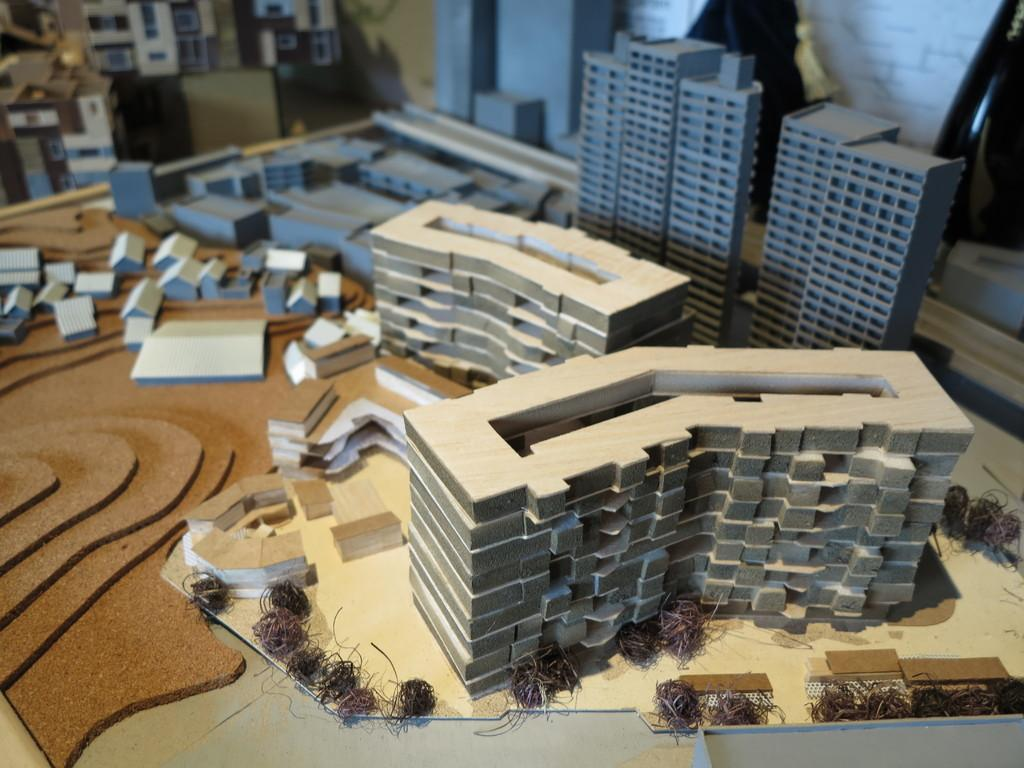What can be seen on the table in the foreground of the image? There is a model representation of a city on a table in the foreground. What is located on the left top of the image? There is another model on the left top of the image. What can be found on the right top of the image? There are objects on the right top of the image. How many apples are visible in the image? There are no apples present in the image. Is there a house in the image? The image does not show a house; it features model representations of a city and other objects. 